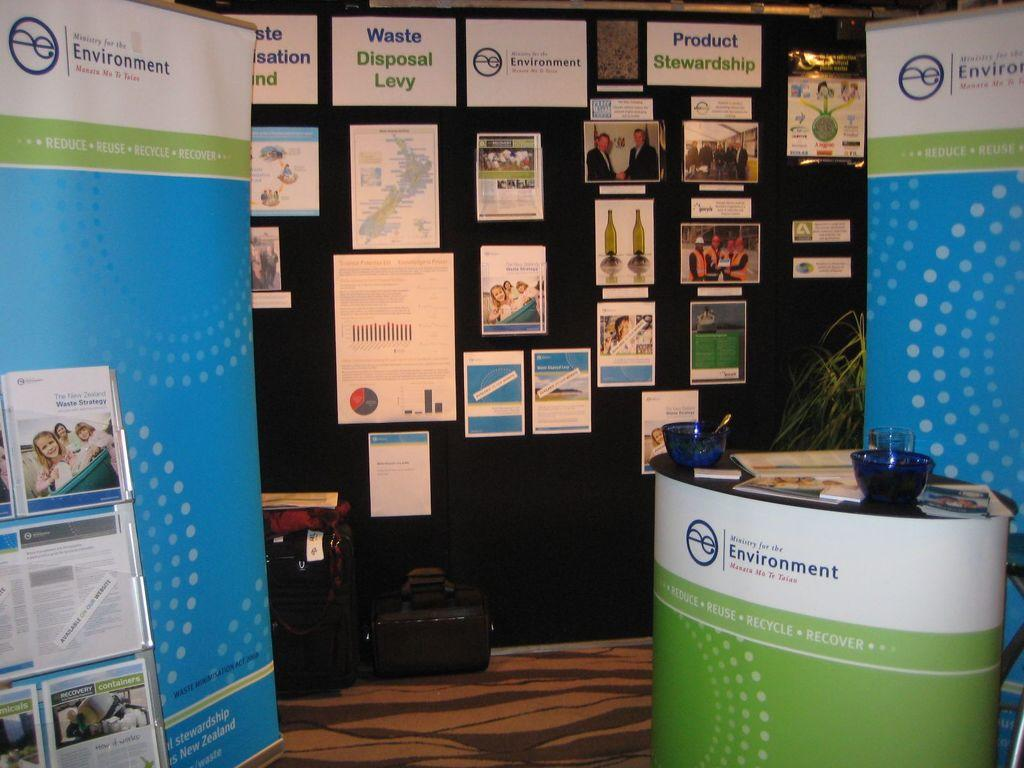<image>
Describe the image concisely. A display area shares information about the environment for people to learn from. 